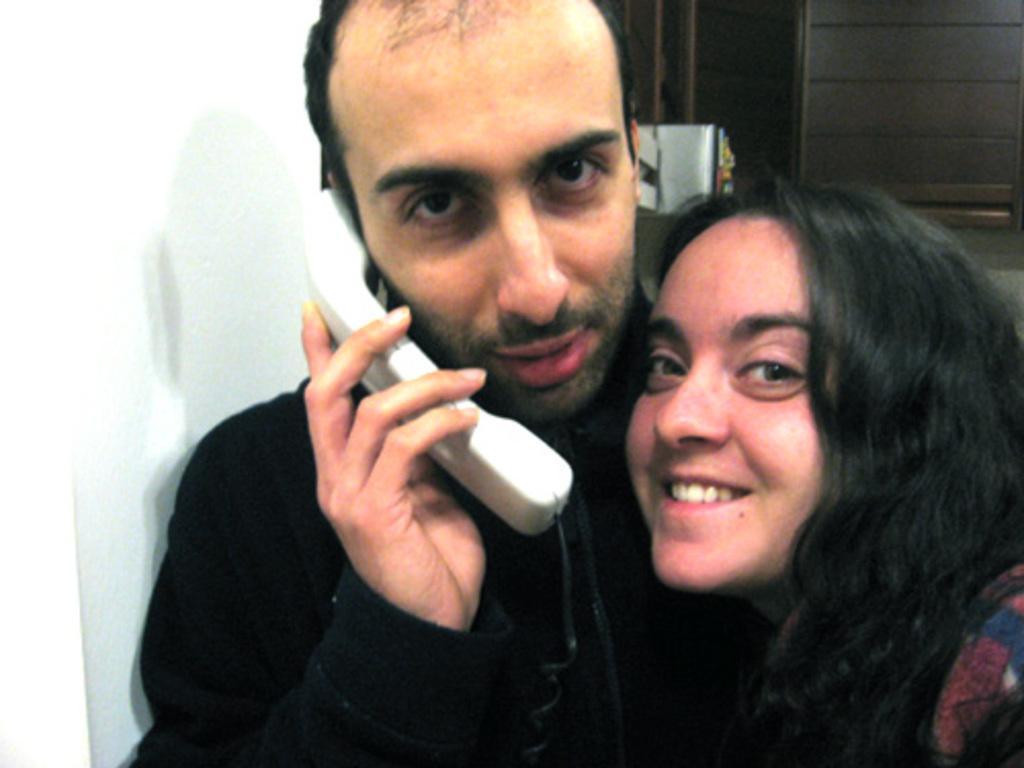Describe this image in one or two sentences. In this image we can see a person holding a phone receiver. Beside him there is a lady. To the left side of the image there is wall. In the background of the image there is a wooden cupboard with some object in it. 